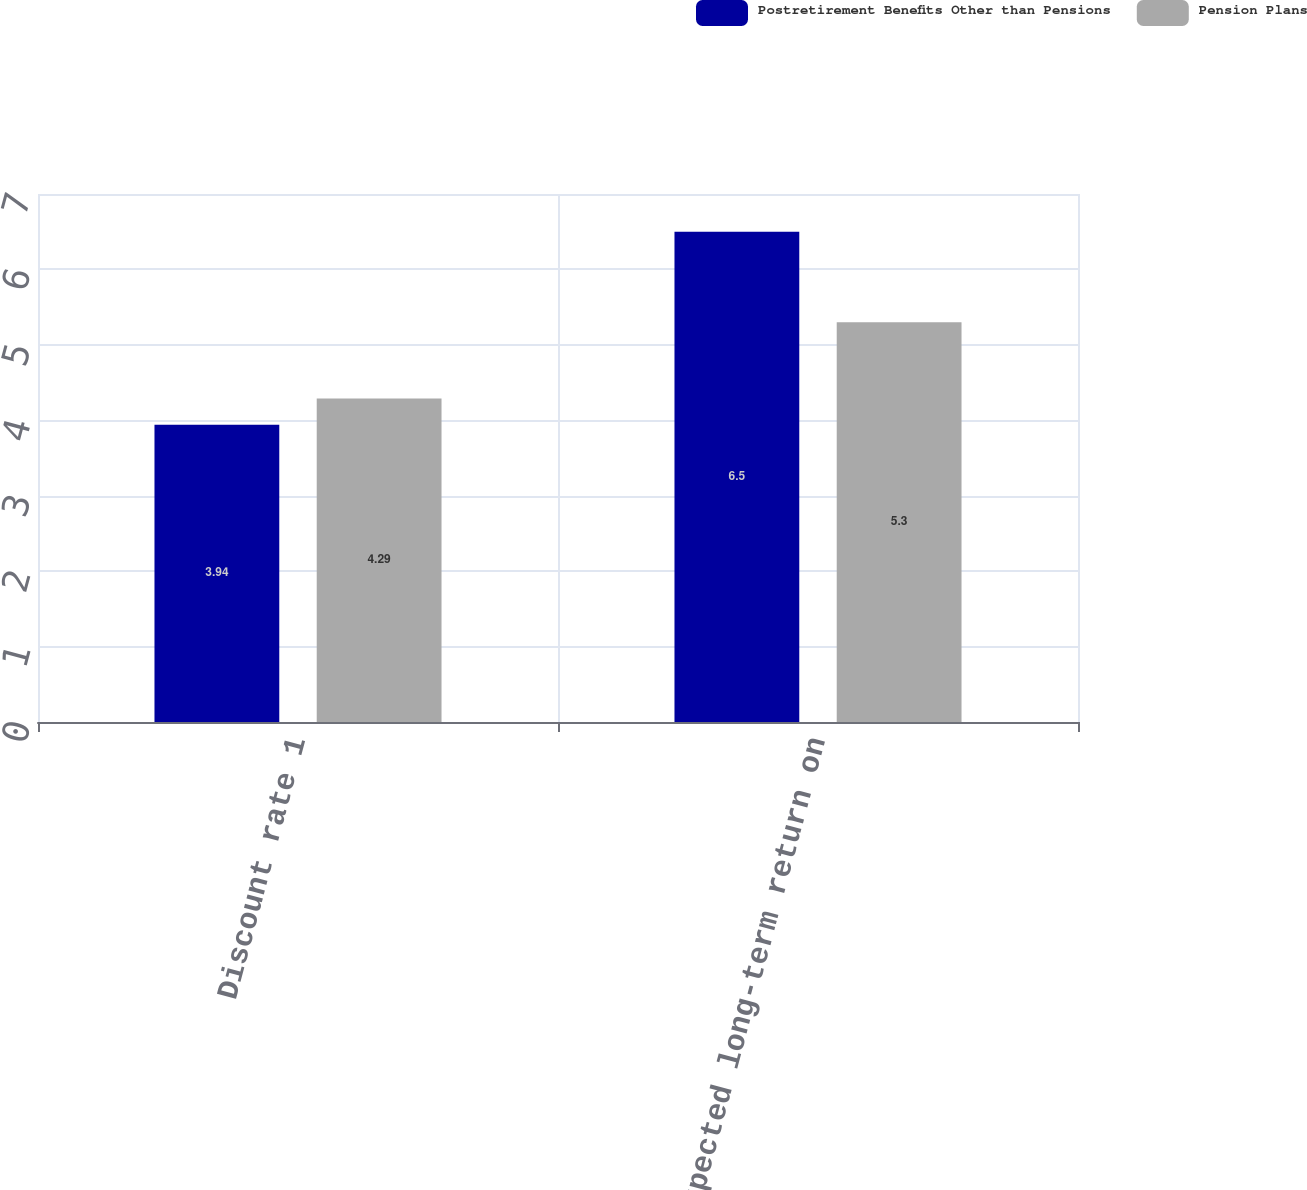Convert chart to OTSL. <chart><loc_0><loc_0><loc_500><loc_500><stacked_bar_chart><ecel><fcel>Discount rate 1<fcel>Expected long-term return on<nl><fcel>Postretirement Benefits Other than Pensions<fcel>3.94<fcel>6.5<nl><fcel>Pension Plans<fcel>4.29<fcel>5.3<nl></chart> 